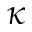Convert formula to latex. <formula><loc_0><loc_0><loc_500><loc_500>\kappa</formula> 